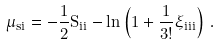Convert formula to latex. <formula><loc_0><loc_0><loc_500><loc_500>\mu _ { s i } = - \frac { 1 } { 2 } S _ { i i } - \ln \left ( 1 + \frac { 1 } { 3 ! } \xi _ { i i i } \right ) \, .</formula> 